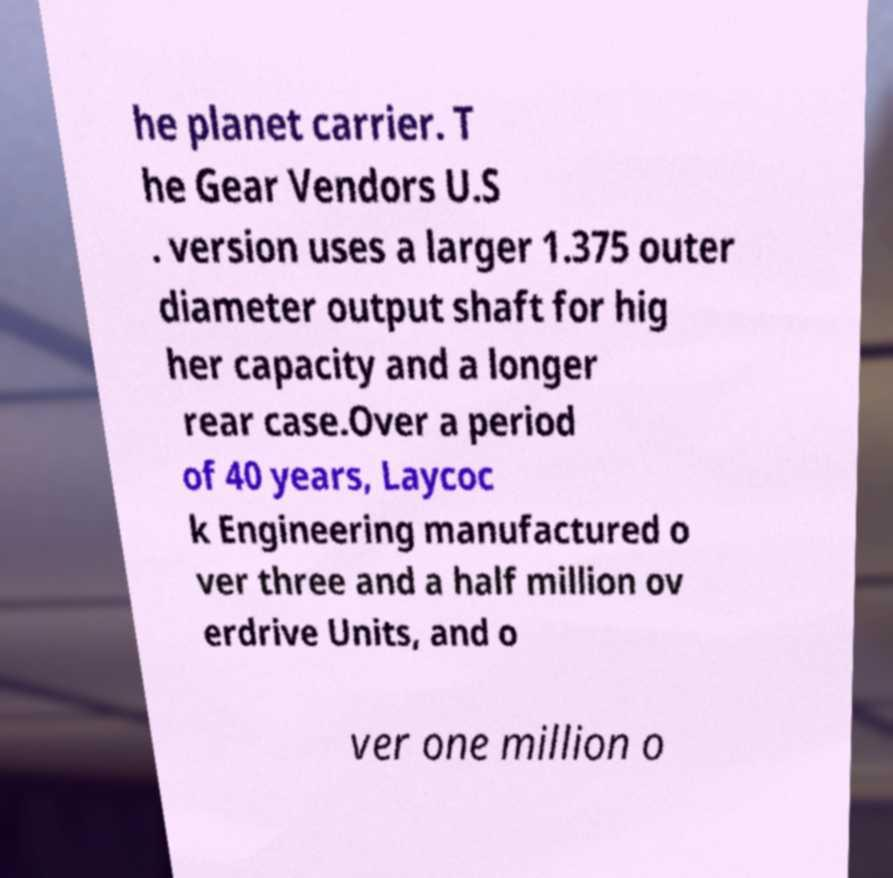Please read and relay the text visible in this image. What does it say? he planet carrier. T he Gear Vendors U.S . version uses a larger 1.375 outer diameter output shaft for hig her capacity and a longer rear case.Over a period of 40 years, Laycoc k Engineering manufactured o ver three and a half million ov erdrive Units, and o ver one million o 